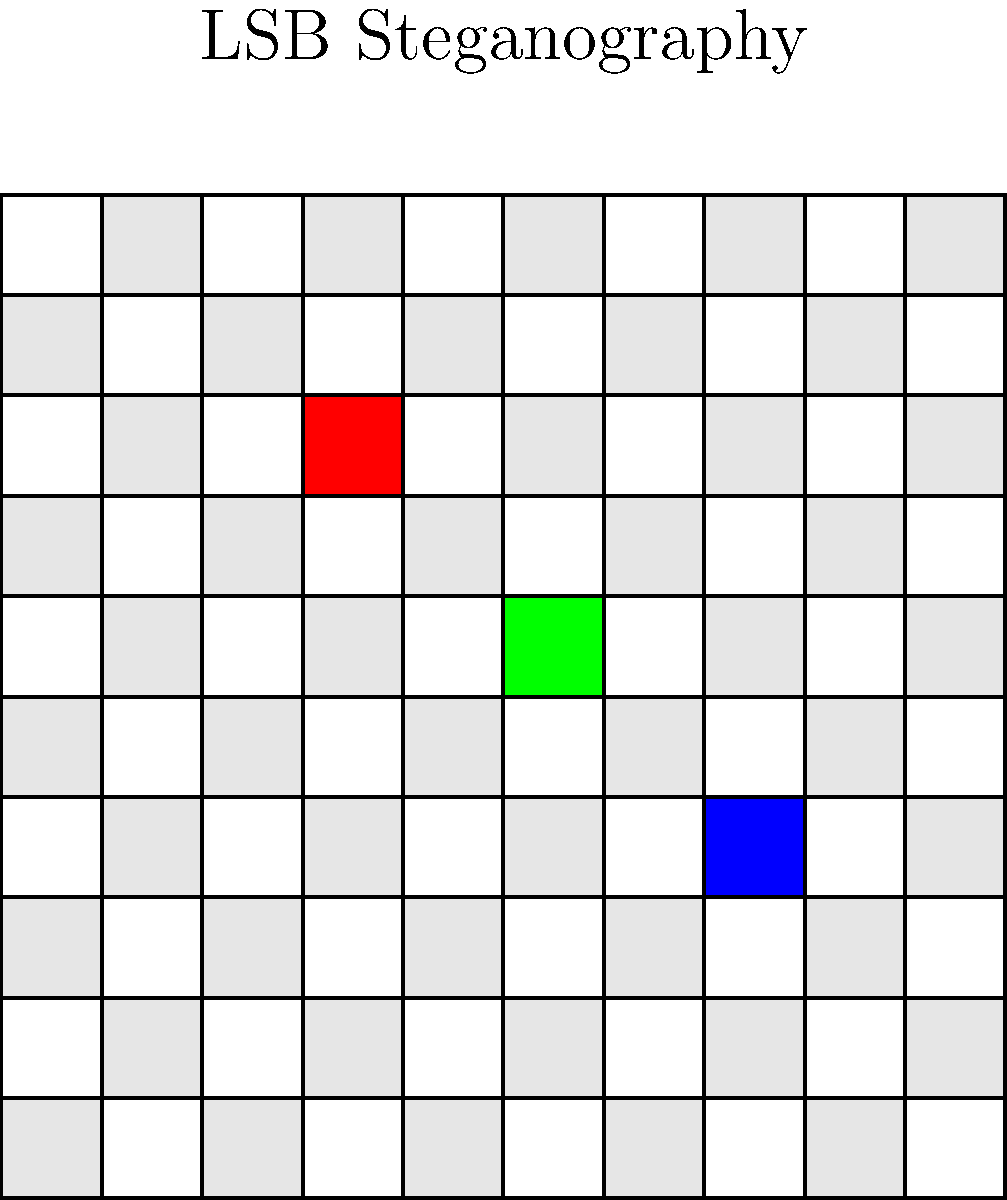In the context of image steganography, what technique is likely being employed in the graphic above, and how might a machine learning model be trained to detect it? 1. Image analysis: The graphic shows a pixelated image with three distinctly colored pixels (red, green, and blue) among a checkerboard pattern of light gray and white pixels.

2. Steganography technique identification: This representation suggests the use of Least Significant Bit (LSB) steganography. In LSB steganography, the least significant bits of pixel color values are modified to hide information.

3. Machine learning approach:
   a) Data collection: Gather a large dataset of images, both with and without hidden messages using LSB steganography.
   b) Feature extraction: Extract relevant features from images, such as:
      - Statistical properties of pixel values
      - Frequency domain analysis (e.g., DCT coefficients)
      - Color histogram analysis
   c) Model selection: Choose an appropriate ML model, such as Convolutional Neural Networks (CNNs) or Support Vector Machines (SVMs).
   d) Training: Train the model on the labeled dataset, teaching it to distinguish between normal images and those with LSB steganography.
   e) Validation and testing: Use cross-validation and a separate test set to evaluate the model's performance.

4. Detection process:
   The trained model would analyze input images, looking for subtle patterns and anomalies in the least significant bits of pixel values that are characteristic of LSB steganography.

5. Challenges:
   - Dealing with various image formats and color depths
   - Distinguishing between intentional steganography and natural image noise
   - Adapting to new steganographic techniques

6. Continuous improvement:
   Regularly update the model with new data and emerging steganographic methods to maintain its effectiveness in CTF competitions.
Answer: LSB steganography; CNN/SVM trained on statistical features and frequency domain analysis of images with/without hidden data 